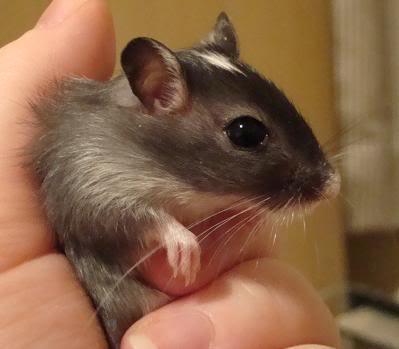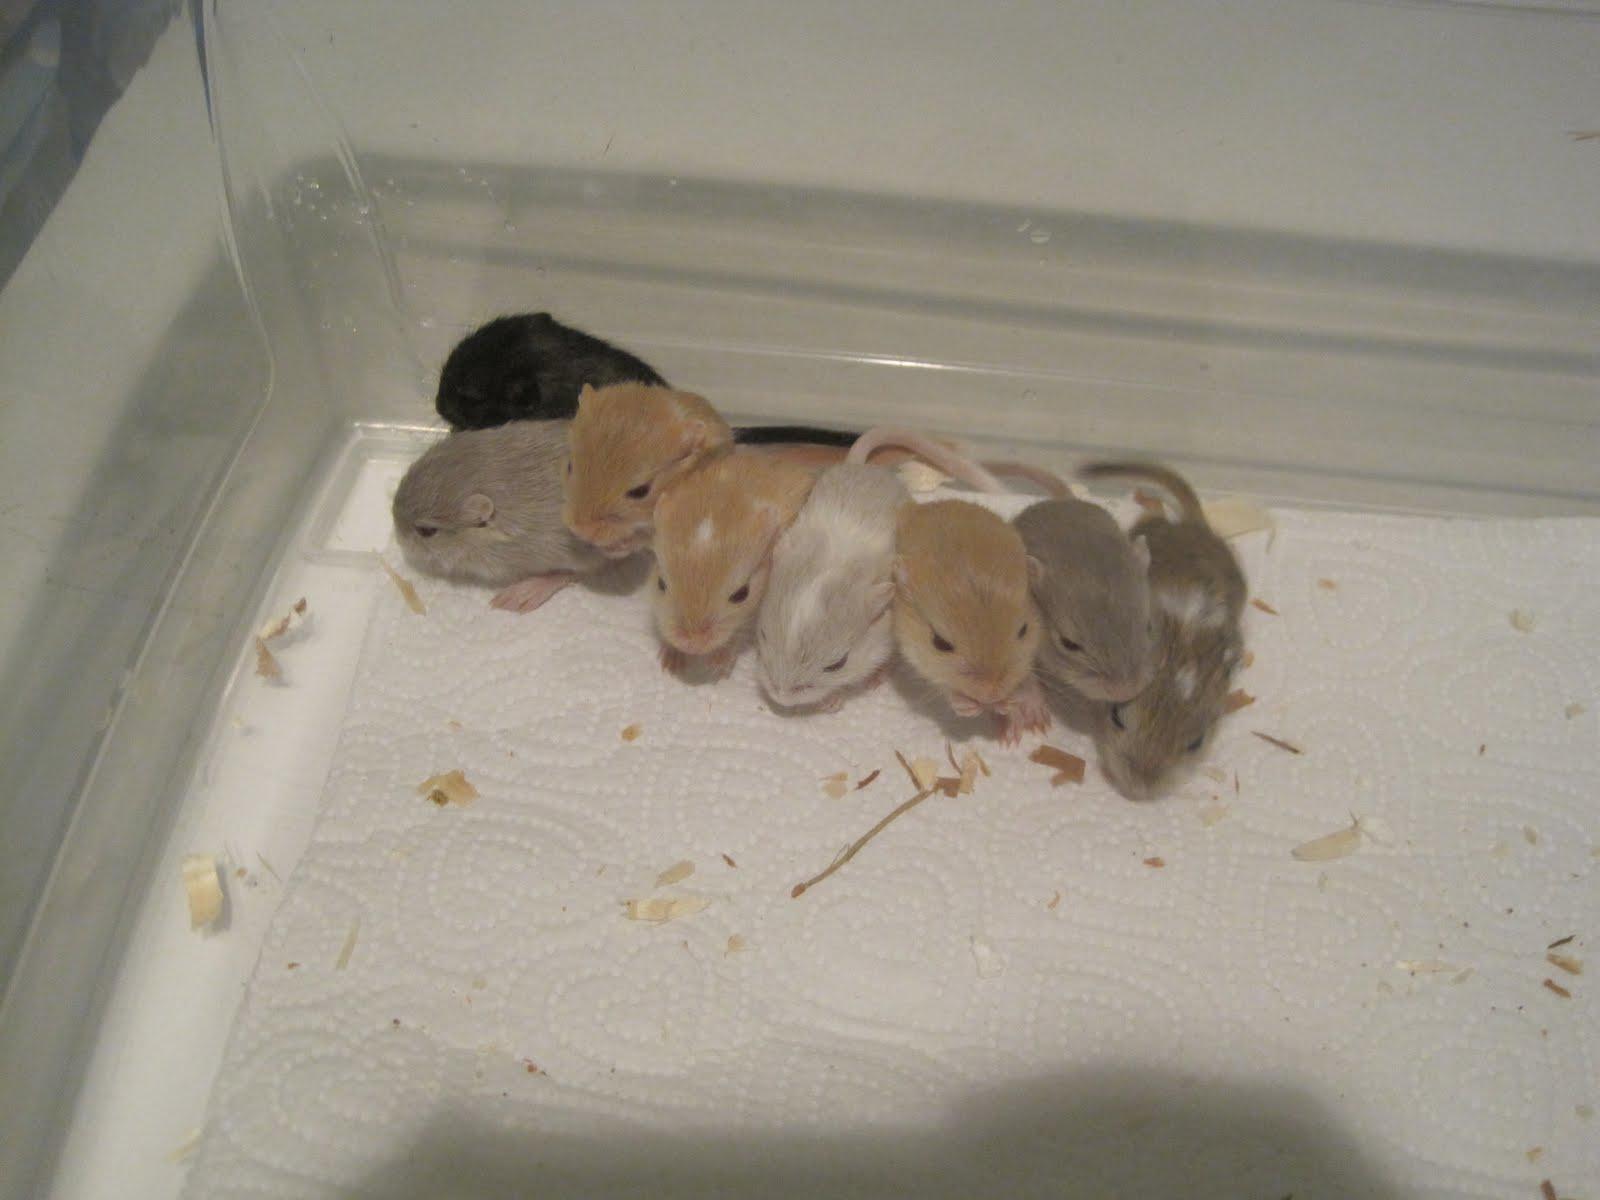The first image is the image on the left, the second image is the image on the right. Evaluate the accuracy of this statement regarding the images: "At least one of the rodents is resting in a human hand.". Is it true? Answer yes or no. Yes. The first image is the image on the left, the second image is the image on the right. Given the left and right images, does the statement "In one of the images, at least one rodent is being held by a human hand." hold true? Answer yes or no. Yes. 